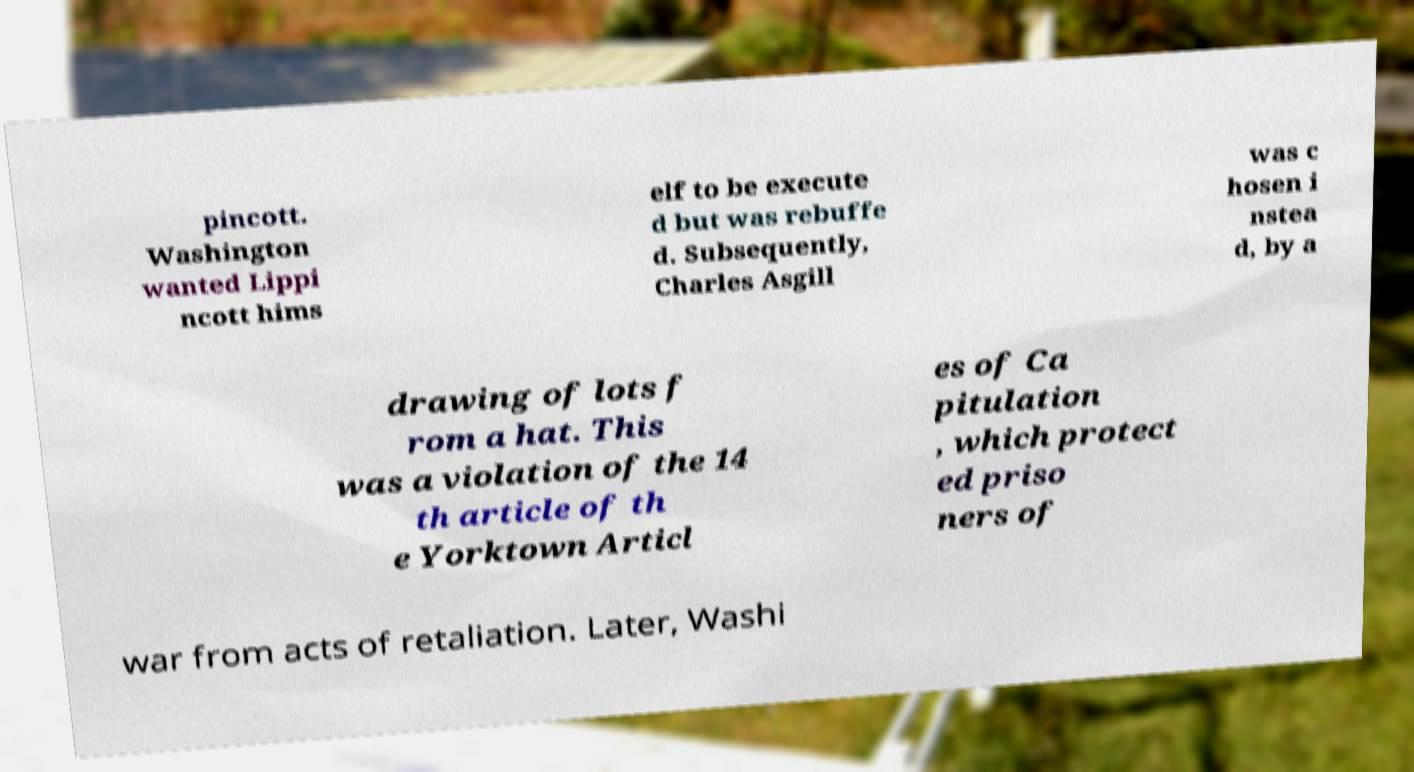I need the written content from this picture converted into text. Can you do that? pincott. Washington wanted Lippi ncott hims elf to be execute d but was rebuffe d. Subsequently, Charles Asgill was c hosen i nstea d, by a drawing of lots f rom a hat. This was a violation of the 14 th article of th e Yorktown Articl es of Ca pitulation , which protect ed priso ners of war from acts of retaliation. Later, Washi 